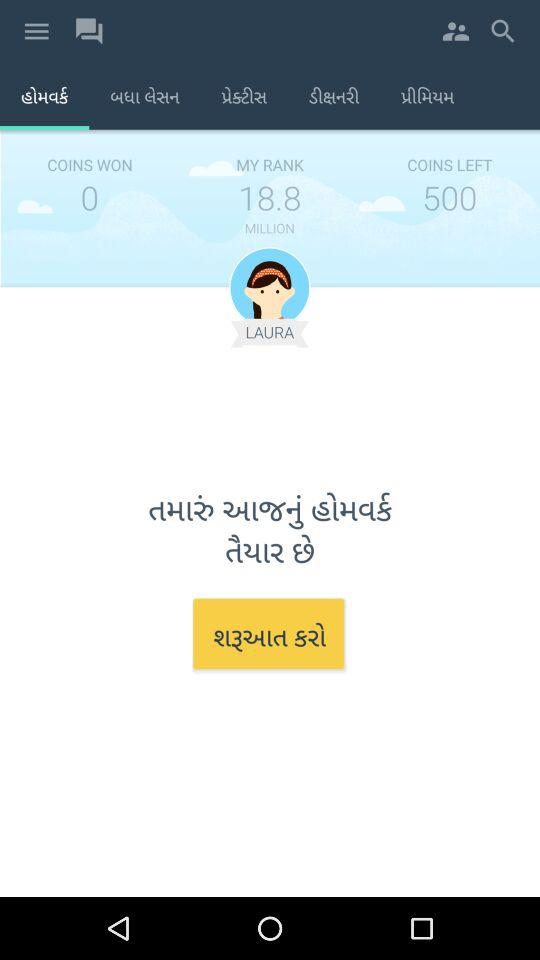How many coins have I left?
Answer the question using a single word or phrase. 500 